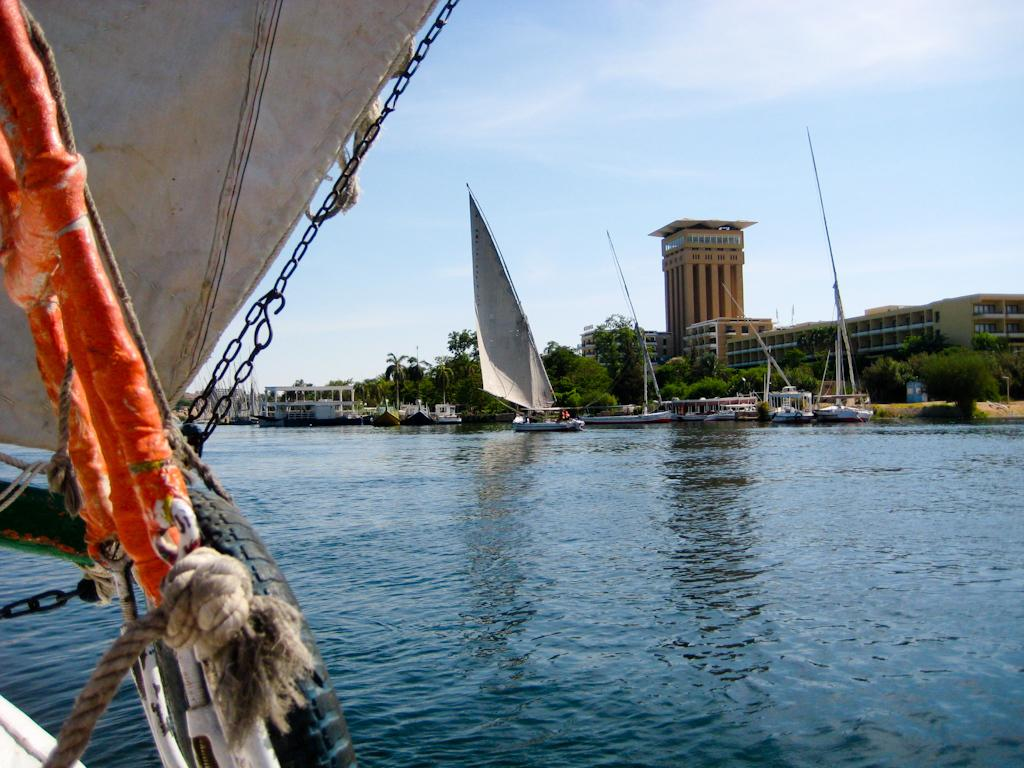What objects can be seen in the foreground of the image? In the foreground of the image, there are rods, a rope, a mainsail, and a boom of a boat. What can be seen in the background of the image? In the background of the image, there is water, boats, buildings, trees, sky, and clouds. How many types of objects are visible in the foreground? There are four types of objects visible in the foreground: rods, rope, mainsail, and boom of a boat. What type of natural environment is visible in the background? The natural environment visible in the background includes water, trees, and sky. What type of grain is being harvested in the image? There is no grain present in the image; it features a boat with a mainsail and other related objects. What is the cause of the clouds in the image? The cause of the clouds in the image cannot be determined from the image itself, as it only shows a boat and its surroundings. 